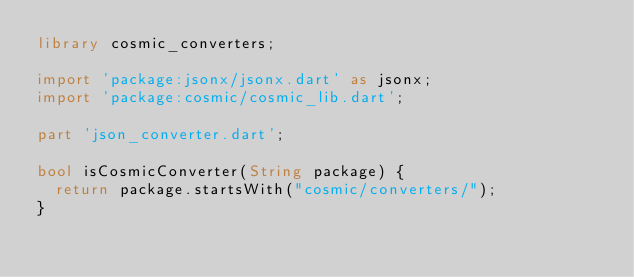Convert code to text. <code><loc_0><loc_0><loc_500><loc_500><_Dart_>library cosmic_converters;

import 'package:jsonx/jsonx.dart' as jsonx;
import 'package:cosmic/cosmic_lib.dart';

part 'json_converter.dart';

bool isCosmicConverter(String package) {
  return package.startsWith("cosmic/converters/");
}</code> 